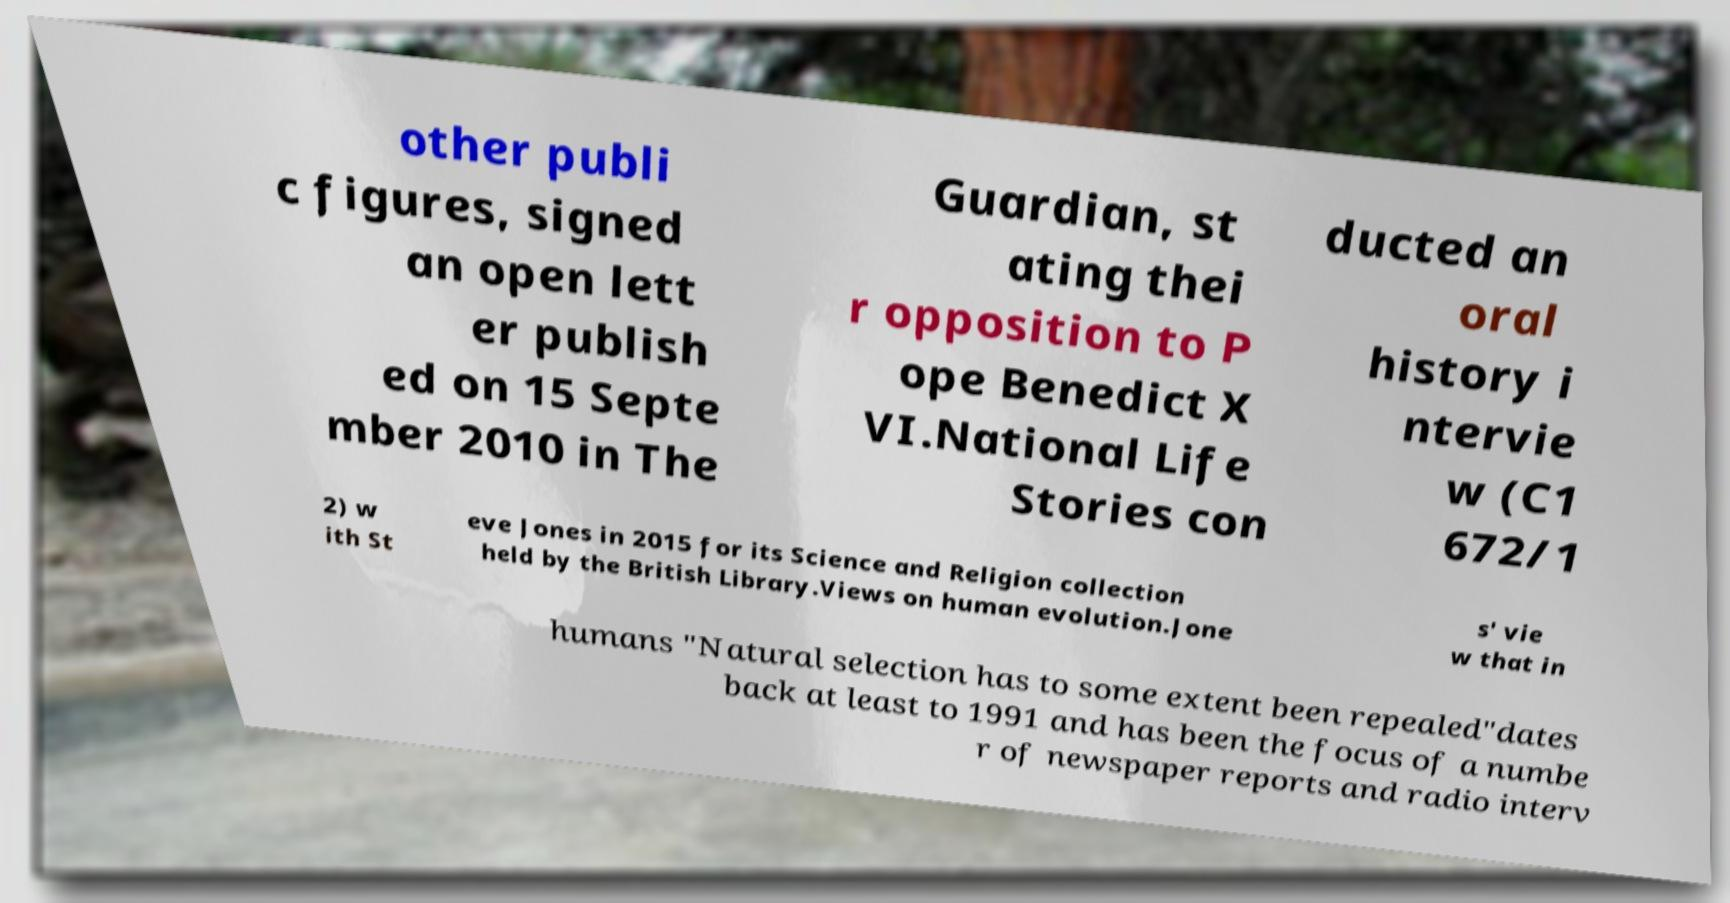I need the written content from this picture converted into text. Can you do that? other publi c figures, signed an open lett er publish ed on 15 Septe mber 2010 in The Guardian, st ating thei r opposition to P ope Benedict X VI.National Life Stories con ducted an oral history i ntervie w (C1 672/1 2) w ith St eve Jones in 2015 for its Science and Religion collection held by the British Library.Views on human evolution.Jone s' vie w that in humans "Natural selection has to some extent been repealed"dates back at least to 1991 and has been the focus of a numbe r of newspaper reports and radio interv 